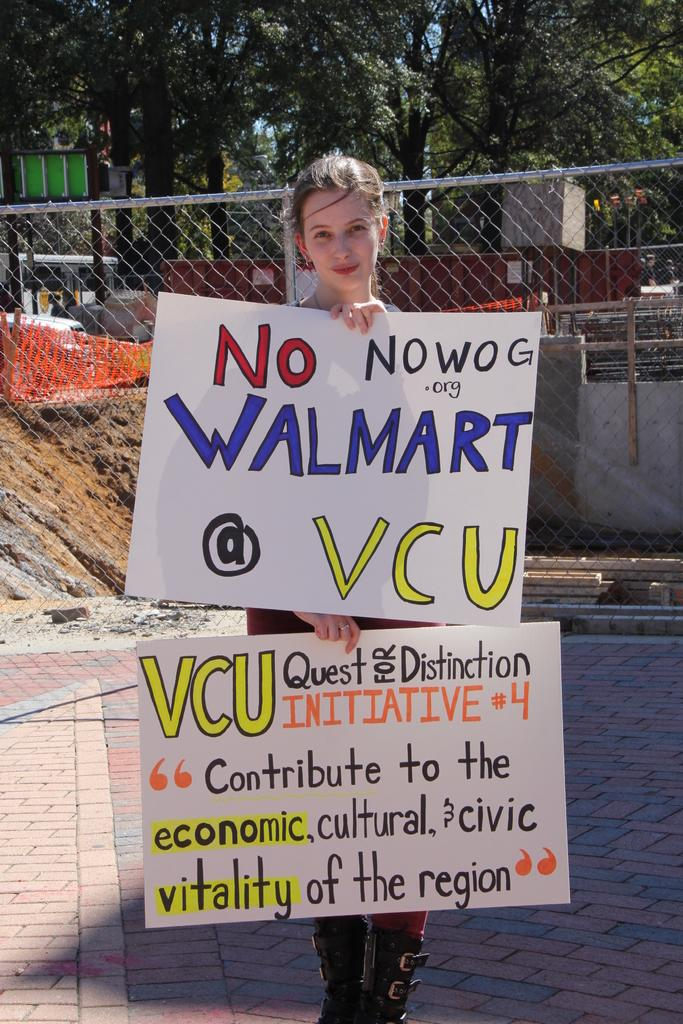What is the main subject of the image? The main subject of the image is a woman standing. What is the woman wearing in the image? The woman is wearing clothes and boots in the image. What is the woman holding in the image? The woman is holding two posters in her hand in the image. What type of path can be seen in the image? There is a footpath in the image. What type of barrier can be seen in the image? There is a fence in the image. What type of structure can be seen in the image? There is a wall in the image. What type of sign can be seen in the image? A: There is a board in the image. What type of vegetation can be seen in the image? There are trees in the image. What type of plants are growing on the hook in the image? There is no hook or plants present in the image. How many cakes can be seen on the board in the image? There are no cakes present in the image; the board is blank. 